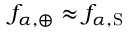<formula> <loc_0><loc_0><loc_500><loc_500>f _ { \alpha , \oplus } \approx f _ { \alpha , S }</formula> 